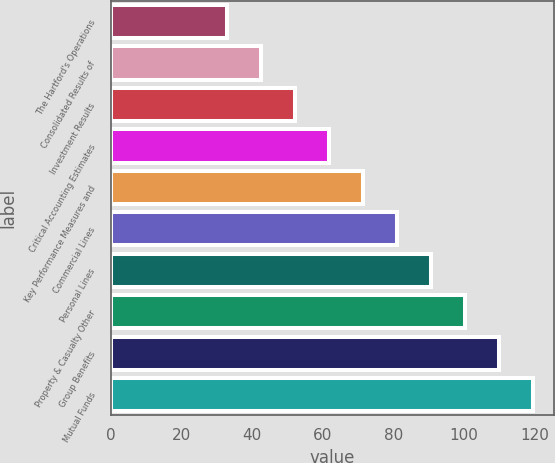<chart> <loc_0><loc_0><loc_500><loc_500><bar_chart><fcel>The Hartford's Operations<fcel>Consolidated Results of<fcel>Investment Results<fcel>Critical Accounting Estimates<fcel>Key Performance Measures and<fcel>Commercial Lines<fcel>Personal Lines<fcel>Property & Casualty Other<fcel>Group Benefits<fcel>Mutual Funds<nl><fcel>33<fcel>42.6<fcel>52.2<fcel>61.8<fcel>71.4<fcel>81<fcel>90.6<fcel>100.2<fcel>109.8<fcel>119.4<nl></chart> 